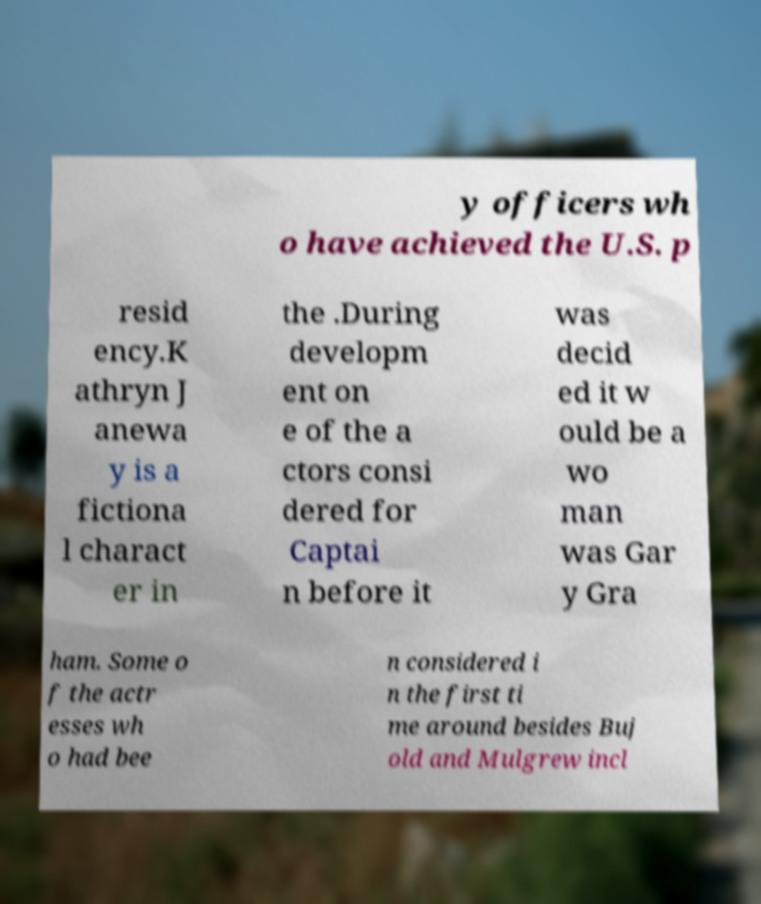Can you accurately transcribe the text from the provided image for me? y officers wh o have achieved the U.S. p resid ency.K athryn J anewa y is a fictiona l charact er in the .During developm ent on e of the a ctors consi dered for Captai n before it was decid ed it w ould be a wo man was Gar y Gra ham. Some o f the actr esses wh o had bee n considered i n the first ti me around besides Buj old and Mulgrew incl 